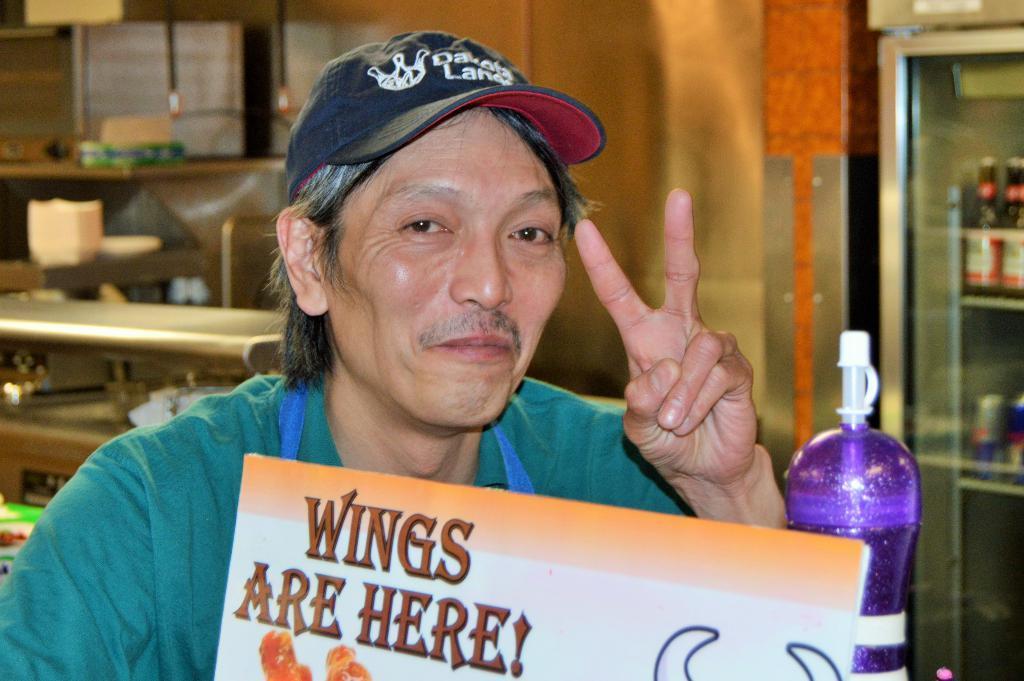Can you describe this image briefly? This picture shows a man Seated on the chair with a smile on his face and he holds a placard in his hand and we see a bottle. 